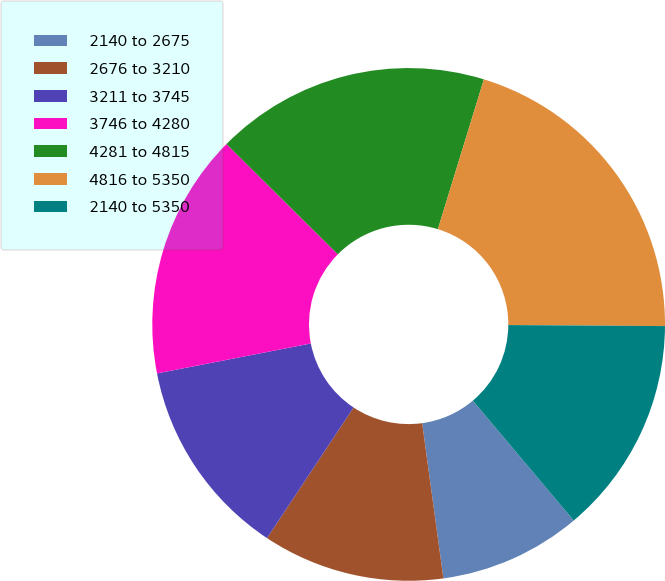Convert chart. <chart><loc_0><loc_0><loc_500><loc_500><pie_chart><fcel>2140 to 2675<fcel>2676 to 3210<fcel>3211 to 3745<fcel>3746 to 4280<fcel>4281 to 4815<fcel>4816 to 5350<fcel>2140 to 5350<nl><fcel>8.97%<fcel>11.48%<fcel>12.62%<fcel>15.48%<fcel>17.32%<fcel>20.36%<fcel>13.76%<nl></chart> 